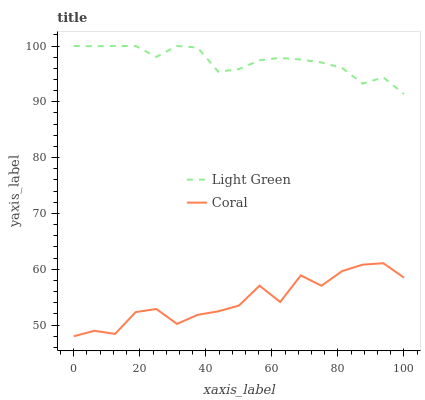Does Light Green have the minimum area under the curve?
Answer yes or no. No. Is Light Green the roughest?
Answer yes or no. No. Does Light Green have the lowest value?
Answer yes or no. No. Is Coral less than Light Green?
Answer yes or no. Yes. Is Light Green greater than Coral?
Answer yes or no. Yes. Does Coral intersect Light Green?
Answer yes or no. No. 